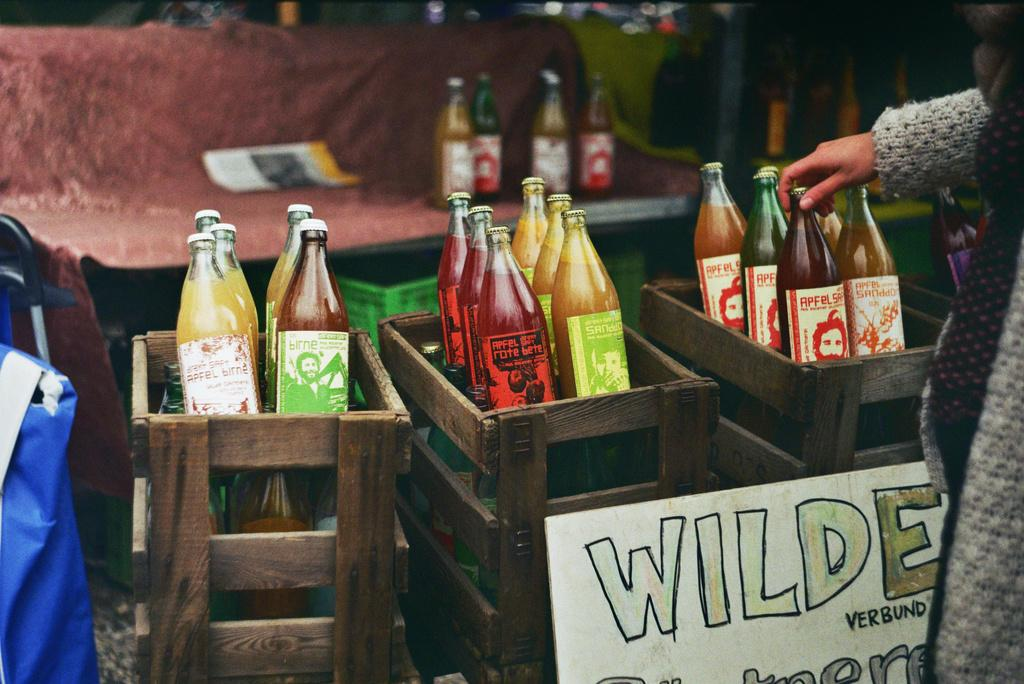What objects are present in the image? There are bottles in the image. How are the bottles arranged or stored? The bottles are in boxes. Can you identify any human presence in the image? Yes, there is a hand of a person visible in the image. What type of question is being asked by the face in the image? There is no face present in the image, so it is not possible to determine what type of question might be asked. 